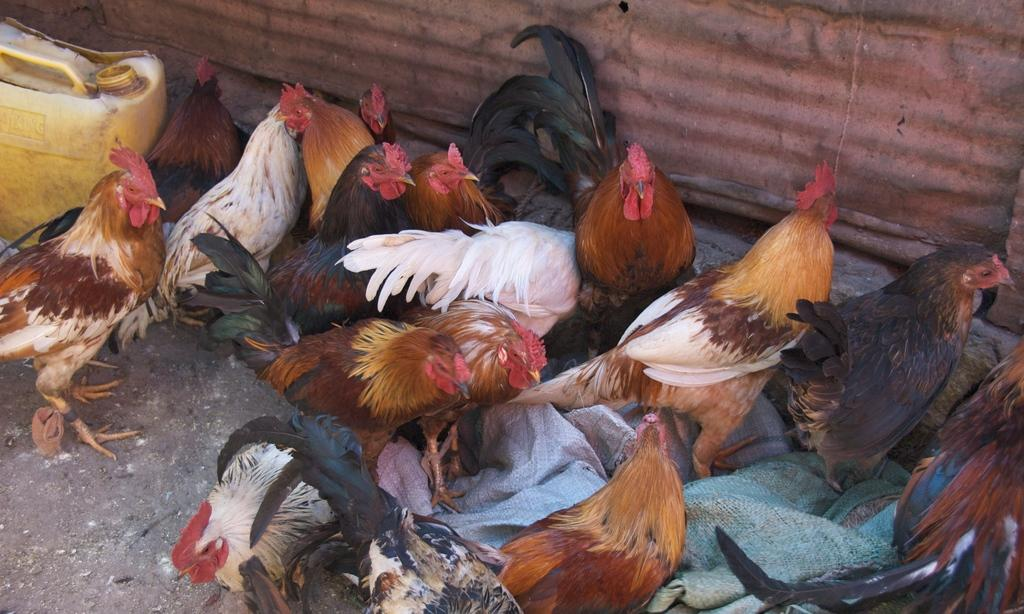What type of animals are in the image? There is a group of hens in the image. What are the hens doing in the image? The hens are standing. Can you describe any other objects in the image? Yes, there is a yellow-colored can in the image. What type of protest is being held by the hens in the image? There is no protest being held by the hens in the image; they are simply standing. What type of advertisement is being displayed on the yellow-colored can in the image? There is no advertisement displayed on the yellow-colored can in the image; it is simply a can. 